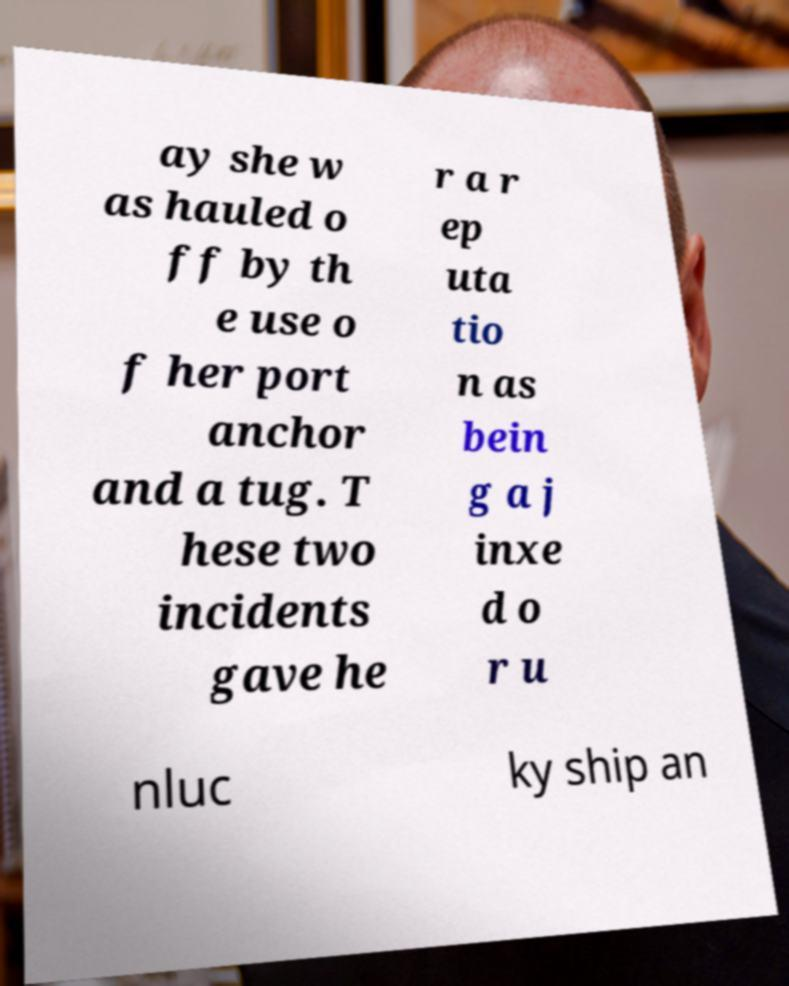Can you read and provide the text displayed in the image?This photo seems to have some interesting text. Can you extract and type it out for me? ay she w as hauled o ff by th e use o f her port anchor and a tug. T hese two incidents gave he r a r ep uta tio n as bein g a j inxe d o r u nluc ky ship an 